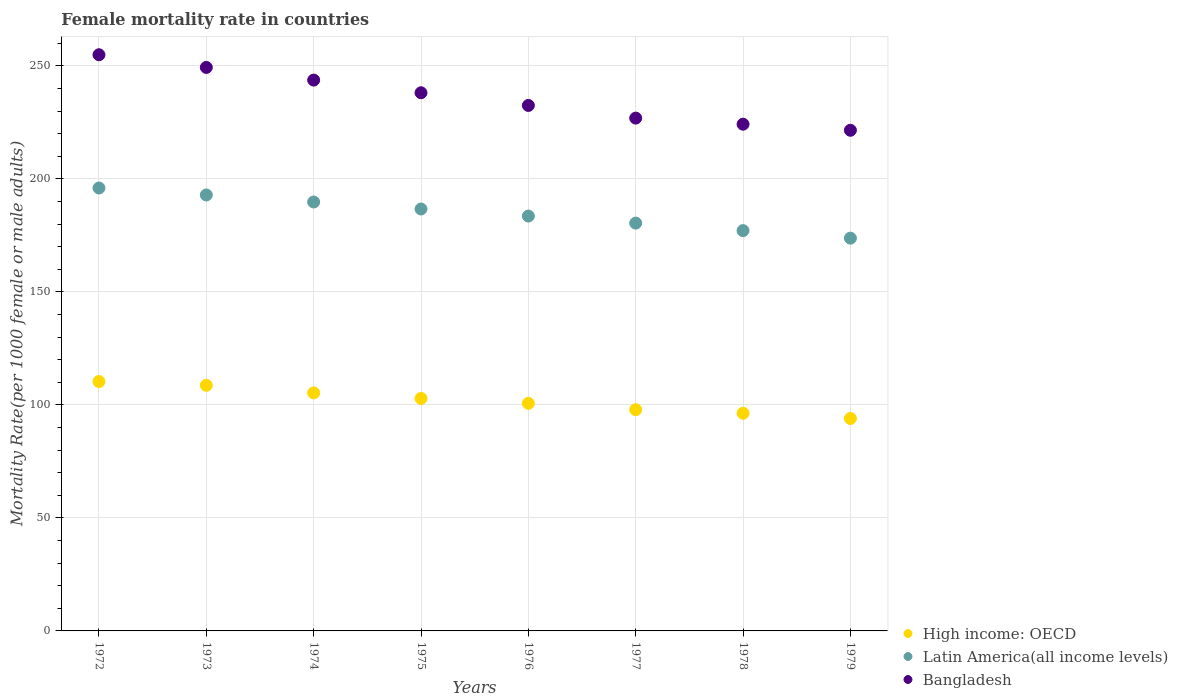Is the number of dotlines equal to the number of legend labels?
Your answer should be very brief. Yes. What is the female mortality rate in High income: OECD in 1976?
Provide a short and direct response. 100.7. Across all years, what is the maximum female mortality rate in High income: OECD?
Your answer should be very brief. 110.35. Across all years, what is the minimum female mortality rate in Bangladesh?
Offer a very short reply. 221.51. In which year was the female mortality rate in Latin America(all income levels) minimum?
Your answer should be compact. 1979. What is the total female mortality rate in Bangladesh in the graph?
Offer a very short reply. 1891.15. What is the difference between the female mortality rate in High income: OECD in 1977 and that in 1979?
Your response must be concise. 3.89. What is the difference between the female mortality rate in Latin America(all income levels) in 1975 and the female mortality rate in Bangladesh in 1978?
Keep it short and to the point. -37.52. What is the average female mortality rate in Bangladesh per year?
Keep it short and to the point. 236.39. In the year 1978, what is the difference between the female mortality rate in High income: OECD and female mortality rate in Bangladesh?
Ensure brevity in your answer.  -127.9. What is the ratio of the female mortality rate in Latin America(all income levels) in 1972 to that in 1975?
Ensure brevity in your answer.  1.05. Is the female mortality rate in Latin America(all income levels) in 1976 less than that in 1978?
Provide a short and direct response. No. Is the difference between the female mortality rate in High income: OECD in 1973 and 1974 greater than the difference between the female mortality rate in Bangladesh in 1973 and 1974?
Offer a very short reply. No. What is the difference between the highest and the second highest female mortality rate in Bangladesh?
Your answer should be very brief. 5.61. What is the difference between the highest and the lowest female mortality rate in Bangladesh?
Keep it short and to the point. 33.41. Is it the case that in every year, the sum of the female mortality rate in Bangladesh and female mortality rate in High income: OECD  is greater than the female mortality rate in Latin America(all income levels)?
Offer a terse response. Yes. Does the female mortality rate in Latin America(all income levels) monotonically increase over the years?
Ensure brevity in your answer.  No. Is the female mortality rate in Latin America(all income levels) strictly greater than the female mortality rate in High income: OECD over the years?
Your response must be concise. Yes. Is the female mortality rate in Bangladesh strictly less than the female mortality rate in High income: OECD over the years?
Make the answer very short. No. What is the title of the graph?
Keep it short and to the point. Female mortality rate in countries. Does "Small states" appear as one of the legend labels in the graph?
Offer a very short reply. No. What is the label or title of the X-axis?
Offer a terse response. Years. What is the label or title of the Y-axis?
Keep it short and to the point. Mortality Rate(per 1000 female or male adults). What is the Mortality Rate(per 1000 female or male adults) in High income: OECD in 1972?
Ensure brevity in your answer.  110.35. What is the Mortality Rate(per 1000 female or male adults) in Latin America(all income levels) in 1972?
Give a very brief answer. 195.97. What is the Mortality Rate(per 1000 female or male adults) of Bangladesh in 1972?
Offer a terse response. 254.92. What is the Mortality Rate(per 1000 female or male adults) in High income: OECD in 1973?
Provide a short and direct response. 108.67. What is the Mortality Rate(per 1000 female or male adults) in Latin America(all income levels) in 1973?
Provide a short and direct response. 192.88. What is the Mortality Rate(per 1000 female or male adults) in Bangladesh in 1973?
Your answer should be compact. 249.31. What is the Mortality Rate(per 1000 female or male adults) of High income: OECD in 1974?
Ensure brevity in your answer.  105.32. What is the Mortality Rate(per 1000 female or male adults) of Latin America(all income levels) in 1974?
Your answer should be compact. 189.78. What is the Mortality Rate(per 1000 female or male adults) in Bangladesh in 1974?
Your answer should be compact. 243.71. What is the Mortality Rate(per 1000 female or male adults) of High income: OECD in 1975?
Provide a succinct answer. 102.86. What is the Mortality Rate(per 1000 female or male adults) of Latin America(all income levels) in 1975?
Provide a succinct answer. 186.68. What is the Mortality Rate(per 1000 female or male adults) of Bangladesh in 1975?
Give a very brief answer. 238.1. What is the Mortality Rate(per 1000 female or male adults) of High income: OECD in 1976?
Keep it short and to the point. 100.7. What is the Mortality Rate(per 1000 female or male adults) in Latin America(all income levels) in 1976?
Give a very brief answer. 183.56. What is the Mortality Rate(per 1000 female or male adults) in Bangladesh in 1976?
Give a very brief answer. 232.5. What is the Mortality Rate(per 1000 female or male adults) of High income: OECD in 1977?
Your response must be concise. 97.89. What is the Mortality Rate(per 1000 female or male adults) in Latin America(all income levels) in 1977?
Ensure brevity in your answer.  180.43. What is the Mortality Rate(per 1000 female or male adults) in Bangladesh in 1977?
Your answer should be compact. 226.89. What is the Mortality Rate(per 1000 female or male adults) in High income: OECD in 1978?
Provide a succinct answer. 96.3. What is the Mortality Rate(per 1000 female or male adults) of Latin America(all income levels) in 1978?
Your response must be concise. 177.11. What is the Mortality Rate(per 1000 female or male adults) of Bangladesh in 1978?
Offer a terse response. 224.2. What is the Mortality Rate(per 1000 female or male adults) of High income: OECD in 1979?
Give a very brief answer. 94. What is the Mortality Rate(per 1000 female or male adults) in Latin America(all income levels) in 1979?
Provide a short and direct response. 173.78. What is the Mortality Rate(per 1000 female or male adults) of Bangladesh in 1979?
Your response must be concise. 221.51. Across all years, what is the maximum Mortality Rate(per 1000 female or male adults) of High income: OECD?
Make the answer very short. 110.35. Across all years, what is the maximum Mortality Rate(per 1000 female or male adults) in Latin America(all income levels)?
Your answer should be very brief. 195.97. Across all years, what is the maximum Mortality Rate(per 1000 female or male adults) in Bangladesh?
Keep it short and to the point. 254.92. Across all years, what is the minimum Mortality Rate(per 1000 female or male adults) in High income: OECD?
Give a very brief answer. 94. Across all years, what is the minimum Mortality Rate(per 1000 female or male adults) in Latin America(all income levels)?
Provide a succinct answer. 173.78. Across all years, what is the minimum Mortality Rate(per 1000 female or male adults) in Bangladesh?
Your answer should be very brief. 221.51. What is the total Mortality Rate(per 1000 female or male adults) in High income: OECD in the graph?
Offer a very short reply. 816.07. What is the total Mortality Rate(per 1000 female or male adults) in Latin America(all income levels) in the graph?
Give a very brief answer. 1480.19. What is the total Mortality Rate(per 1000 female or male adults) of Bangladesh in the graph?
Your response must be concise. 1891.15. What is the difference between the Mortality Rate(per 1000 female or male adults) of High income: OECD in 1972 and that in 1973?
Keep it short and to the point. 1.68. What is the difference between the Mortality Rate(per 1000 female or male adults) of Latin America(all income levels) in 1972 and that in 1973?
Your answer should be very brief. 3.09. What is the difference between the Mortality Rate(per 1000 female or male adults) in Bangladesh in 1972 and that in 1973?
Ensure brevity in your answer.  5.61. What is the difference between the Mortality Rate(per 1000 female or male adults) in High income: OECD in 1972 and that in 1974?
Offer a terse response. 5.03. What is the difference between the Mortality Rate(per 1000 female or male adults) of Latin America(all income levels) in 1972 and that in 1974?
Provide a short and direct response. 6.19. What is the difference between the Mortality Rate(per 1000 female or male adults) of Bangladesh in 1972 and that in 1974?
Provide a short and direct response. 11.21. What is the difference between the Mortality Rate(per 1000 female or male adults) in High income: OECD in 1972 and that in 1975?
Make the answer very short. 7.49. What is the difference between the Mortality Rate(per 1000 female or male adults) of Latin America(all income levels) in 1972 and that in 1975?
Give a very brief answer. 9.3. What is the difference between the Mortality Rate(per 1000 female or male adults) in Bangladesh in 1972 and that in 1975?
Provide a short and direct response. 16.82. What is the difference between the Mortality Rate(per 1000 female or male adults) in High income: OECD in 1972 and that in 1976?
Make the answer very short. 9.64. What is the difference between the Mortality Rate(per 1000 female or male adults) in Latin America(all income levels) in 1972 and that in 1976?
Your answer should be very brief. 12.42. What is the difference between the Mortality Rate(per 1000 female or male adults) in Bangladesh in 1972 and that in 1976?
Make the answer very short. 22.42. What is the difference between the Mortality Rate(per 1000 female or male adults) of High income: OECD in 1972 and that in 1977?
Your answer should be very brief. 12.46. What is the difference between the Mortality Rate(per 1000 female or male adults) in Latin America(all income levels) in 1972 and that in 1977?
Ensure brevity in your answer.  15.54. What is the difference between the Mortality Rate(per 1000 female or male adults) in Bangladesh in 1972 and that in 1977?
Give a very brief answer. 28.03. What is the difference between the Mortality Rate(per 1000 female or male adults) in High income: OECD in 1972 and that in 1978?
Offer a very short reply. 14.05. What is the difference between the Mortality Rate(per 1000 female or male adults) in Latin America(all income levels) in 1972 and that in 1978?
Give a very brief answer. 18.86. What is the difference between the Mortality Rate(per 1000 female or male adults) in Bangladesh in 1972 and that in 1978?
Your response must be concise. 30.72. What is the difference between the Mortality Rate(per 1000 female or male adults) in High income: OECD in 1972 and that in 1979?
Your answer should be very brief. 16.35. What is the difference between the Mortality Rate(per 1000 female or male adults) of Latin America(all income levels) in 1972 and that in 1979?
Offer a very short reply. 22.19. What is the difference between the Mortality Rate(per 1000 female or male adults) in Bangladesh in 1972 and that in 1979?
Offer a very short reply. 33.41. What is the difference between the Mortality Rate(per 1000 female or male adults) in High income: OECD in 1973 and that in 1974?
Give a very brief answer. 3.35. What is the difference between the Mortality Rate(per 1000 female or male adults) in Latin America(all income levels) in 1973 and that in 1974?
Provide a succinct answer. 3.1. What is the difference between the Mortality Rate(per 1000 female or male adults) of Bangladesh in 1973 and that in 1974?
Provide a short and direct response. 5.61. What is the difference between the Mortality Rate(per 1000 female or male adults) of High income: OECD in 1973 and that in 1975?
Your response must be concise. 5.81. What is the difference between the Mortality Rate(per 1000 female or male adults) of Latin America(all income levels) in 1973 and that in 1975?
Make the answer very short. 6.2. What is the difference between the Mortality Rate(per 1000 female or male adults) in Bangladesh in 1973 and that in 1975?
Give a very brief answer. 11.21. What is the difference between the Mortality Rate(per 1000 female or male adults) of High income: OECD in 1973 and that in 1976?
Make the answer very short. 7.96. What is the difference between the Mortality Rate(per 1000 female or male adults) of Latin America(all income levels) in 1973 and that in 1976?
Offer a very short reply. 9.32. What is the difference between the Mortality Rate(per 1000 female or male adults) in Bangladesh in 1973 and that in 1976?
Make the answer very short. 16.82. What is the difference between the Mortality Rate(per 1000 female or male adults) of High income: OECD in 1973 and that in 1977?
Give a very brief answer. 10.78. What is the difference between the Mortality Rate(per 1000 female or male adults) in Latin America(all income levels) in 1973 and that in 1977?
Provide a short and direct response. 12.45. What is the difference between the Mortality Rate(per 1000 female or male adults) in Bangladesh in 1973 and that in 1977?
Give a very brief answer. 22.42. What is the difference between the Mortality Rate(per 1000 female or male adults) of High income: OECD in 1973 and that in 1978?
Ensure brevity in your answer.  12.37. What is the difference between the Mortality Rate(per 1000 female or male adults) of Latin America(all income levels) in 1973 and that in 1978?
Offer a very short reply. 15.77. What is the difference between the Mortality Rate(per 1000 female or male adults) in Bangladesh in 1973 and that in 1978?
Make the answer very short. 25.11. What is the difference between the Mortality Rate(per 1000 female or male adults) of High income: OECD in 1973 and that in 1979?
Offer a terse response. 14.67. What is the difference between the Mortality Rate(per 1000 female or male adults) of Latin America(all income levels) in 1973 and that in 1979?
Your answer should be compact. 19.1. What is the difference between the Mortality Rate(per 1000 female or male adults) of Bangladesh in 1973 and that in 1979?
Ensure brevity in your answer.  27.8. What is the difference between the Mortality Rate(per 1000 female or male adults) of High income: OECD in 1974 and that in 1975?
Keep it short and to the point. 2.46. What is the difference between the Mortality Rate(per 1000 female or male adults) of Latin America(all income levels) in 1974 and that in 1975?
Keep it short and to the point. 3.1. What is the difference between the Mortality Rate(per 1000 female or male adults) in Bangladesh in 1974 and that in 1975?
Your answer should be compact. 5.61. What is the difference between the Mortality Rate(per 1000 female or male adults) of High income: OECD in 1974 and that in 1976?
Ensure brevity in your answer.  4.61. What is the difference between the Mortality Rate(per 1000 female or male adults) in Latin America(all income levels) in 1974 and that in 1976?
Offer a very short reply. 6.22. What is the difference between the Mortality Rate(per 1000 female or male adults) in Bangladesh in 1974 and that in 1976?
Offer a very short reply. 11.21. What is the difference between the Mortality Rate(per 1000 female or male adults) in High income: OECD in 1974 and that in 1977?
Make the answer very short. 7.43. What is the difference between the Mortality Rate(per 1000 female or male adults) in Latin America(all income levels) in 1974 and that in 1977?
Your answer should be compact. 9.35. What is the difference between the Mortality Rate(per 1000 female or male adults) of Bangladesh in 1974 and that in 1977?
Your answer should be very brief. 16.82. What is the difference between the Mortality Rate(per 1000 female or male adults) in High income: OECD in 1974 and that in 1978?
Your response must be concise. 9.02. What is the difference between the Mortality Rate(per 1000 female or male adults) of Latin America(all income levels) in 1974 and that in 1978?
Your answer should be very brief. 12.67. What is the difference between the Mortality Rate(per 1000 female or male adults) of Bangladesh in 1974 and that in 1978?
Your answer should be compact. 19.51. What is the difference between the Mortality Rate(per 1000 female or male adults) in High income: OECD in 1974 and that in 1979?
Give a very brief answer. 11.32. What is the difference between the Mortality Rate(per 1000 female or male adults) of Latin America(all income levels) in 1974 and that in 1979?
Ensure brevity in your answer.  16. What is the difference between the Mortality Rate(per 1000 female or male adults) of Bangladesh in 1974 and that in 1979?
Your answer should be compact. 22.2. What is the difference between the Mortality Rate(per 1000 female or male adults) in High income: OECD in 1975 and that in 1976?
Provide a succinct answer. 2.16. What is the difference between the Mortality Rate(per 1000 female or male adults) in Latin America(all income levels) in 1975 and that in 1976?
Ensure brevity in your answer.  3.12. What is the difference between the Mortality Rate(per 1000 female or male adults) of Bangladesh in 1975 and that in 1976?
Offer a very short reply. 5.61. What is the difference between the Mortality Rate(per 1000 female or male adults) in High income: OECD in 1975 and that in 1977?
Make the answer very short. 4.97. What is the difference between the Mortality Rate(per 1000 female or male adults) of Latin America(all income levels) in 1975 and that in 1977?
Provide a short and direct response. 6.24. What is the difference between the Mortality Rate(per 1000 female or male adults) of Bangladesh in 1975 and that in 1977?
Your response must be concise. 11.21. What is the difference between the Mortality Rate(per 1000 female or male adults) of High income: OECD in 1975 and that in 1978?
Provide a short and direct response. 6.56. What is the difference between the Mortality Rate(per 1000 female or male adults) in Latin America(all income levels) in 1975 and that in 1978?
Offer a very short reply. 9.57. What is the difference between the Mortality Rate(per 1000 female or male adults) in Bangladesh in 1975 and that in 1978?
Keep it short and to the point. 13.9. What is the difference between the Mortality Rate(per 1000 female or male adults) in High income: OECD in 1975 and that in 1979?
Give a very brief answer. 8.86. What is the difference between the Mortality Rate(per 1000 female or male adults) in Latin America(all income levels) in 1975 and that in 1979?
Your answer should be very brief. 12.89. What is the difference between the Mortality Rate(per 1000 female or male adults) in Bangladesh in 1975 and that in 1979?
Keep it short and to the point. 16.59. What is the difference between the Mortality Rate(per 1000 female or male adults) of High income: OECD in 1976 and that in 1977?
Provide a succinct answer. 2.81. What is the difference between the Mortality Rate(per 1000 female or male adults) of Latin America(all income levels) in 1976 and that in 1977?
Your response must be concise. 3.12. What is the difference between the Mortality Rate(per 1000 female or male adults) of Bangladesh in 1976 and that in 1977?
Keep it short and to the point. 5.61. What is the difference between the Mortality Rate(per 1000 female or male adults) of High income: OECD in 1976 and that in 1978?
Your response must be concise. 4.4. What is the difference between the Mortality Rate(per 1000 female or male adults) in Latin America(all income levels) in 1976 and that in 1978?
Provide a succinct answer. 6.45. What is the difference between the Mortality Rate(per 1000 female or male adults) in Bangladesh in 1976 and that in 1978?
Ensure brevity in your answer.  8.3. What is the difference between the Mortality Rate(per 1000 female or male adults) of High income: OECD in 1976 and that in 1979?
Your answer should be very brief. 6.7. What is the difference between the Mortality Rate(per 1000 female or male adults) in Latin America(all income levels) in 1976 and that in 1979?
Make the answer very short. 9.77. What is the difference between the Mortality Rate(per 1000 female or male adults) of Bangladesh in 1976 and that in 1979?
Provide a succinct answer. 10.99. What is the difference between the Mortality Rate(per 1000 female or male adults) in High income: OECD in 1977 and that in 1978?
Make the answer very short. 1.59. What is the difference between the Mortality Rate(per 1000 female or male adults) in Latin America(all income levels) in 1977 and that in 1978?
Offer a very short reply. 3.32. What is the difference between the Mortality Rate(per 1000 female or male adults) of Bangladesh in 1977 and that in 1978?
Provide a short and direct response. 2.69. What is the difference between the Mortality Rate(per 1000 female or male adults) in High income: OECD in 1977 and that in 1979?
Offer a terse response. 3.89. What is the difference between the Mortality Rate(per 1000 female or male adults) of Latin America(all income levels) in 1977 and that in 1979?
Provide a succinct answer. 6.65. What is the difference between the Mortality Rate(per 1000 female or male adults) of Bangladesh in 1977 and that in 1979?
Offer a very short reply. 5.38. What is the difference between the Mortality Rate(per 1000 female or male adults) in High income: OECD in 1978 and that in 1979?
Provide a short and direct response. 2.3. What is the difference between the Mortality Rate(per 1000 female or male adults) in Latin America(all income levels) in 1978 and that in 1979?
Your response must be concise. 3.33. What is the difference between the Mortality Rate(per 1000 female or male adults) in Bangladesh in 1978 and that in 1979?
Offer a very short reply. 2.69. What is the difference between the Mortality Rate(per 1000 female or male adults) of High income: OECD in 1972 and the Mortality Rate(per 1000 female or male adults) of Latin America(all income levels) in 1973?
Provide a short and direct response. -82.53. What is the difference between the Mortality Rate(per 1000 female or male adults) of High income: OECD in 1972 and the Mortality Rate(per 1000 female or male adults) of Bangladesh in 1973?
Your answer should be very brief. -138.97. What is the difference between the Mortality Rate(per 1000 female or male adults) of Latin America(all income levels) in 1972 and the Mortality Rate(per 1000 female or male adults) of Bangladesh in 1973?
Keep it short and to the point. -53.34. What is the difference between the Mortality Rate(per 1000 female or male adults) of High income: OECD in 1972 and the Mortality Rate(per 1000 female or male adults) of Latin America(all income levels) in 1974?
Your response must be concise. -79.44. What is the difference between the Mortality Rate(per 1000 female or male adults) in High income: OECD in 1972 and the Mortality Rate(per 1000 female or male adults) in Bangladesh in 1974?
Give a very brief answer. -133.36. What is the difference between the Mortality Rate(per 1000 female or male adults) in Latin America(all income levels) in 1972 and the Mortality Rate(per 1000 female or male adults) in Bangladesh in 1974?
Keep it short and to the point. -47.74. What is the difference between the Mortality Rate(per 1000 female or male adults) of High income: OECD in 1972 and the Mortality Rate(per 1000 female or male adults) of Latin America(all income levels) in 1975?
Make the answer very short. -76.33. What is the difference between the Mortality Rate(per 1000 female or male adults) of High income: OECD in 1972 and the Mortality Rate(per 1000 female or male adults) of Bangladesh in 1975?
Give a very brief answer. -127.76. What is the difference between the Mortality Rate(per 1000 female or male adults) of Latin America(all income levels) in 1972 and the Mortality Rate(per 1000 female or male adults) of Bangladesh in 1975?
Your answer should be compact. -42.13. What is the difference between the Mortality Rate(per 1000 female or male adults) of High income: OECD in 1972 and the Mortality Rate(per 1000 female or male adults) of Latin America(all income levels) in 1976?
Provide a short and direct response. -73.21. What is the difference between the Mortality Rate(per 1000 female or male adults) in High income: OECD in 1972 and the Mortality Rate(per 1000 female or male adults) in Bangladesh in 1976?
Your answer should be compact. -122.15. What is the difference between the Mortality Rate(per 1000 female or male adults) of Latin America(all income levels) in 1972 and the Mortality Rate(per 1000 female or male adults) of Bangladesh in 1976?
Offer a very short reply. -36.53. What is the difference between the Mortality Rate(per 1000 female or male adults) in High income: OECD in 1972 and the Mortality Rate(per 1000 female or male adults) in Latin America(all income levels) in 1977?
Offer a very short reply. -70.09. What is the difference between the Mortality Rate(per 1000 female or male adults) in High income: OECD in 1972 and the Mortality Rate(per 1000 female or male adults) in Bangladesh in 1977?
Your answer should be very brief. -116.55. What is the difference between the Mortality Rate(per 1000 female or male adults) of Latin America(all income levels) in 1972 and the Mortality Rate(per 1000 female or male adults) of Bangladesh in 1977?
Provide a short and direct response. -30.92. What is the difference between the Mortality Rate(per 1000 female or male adults) of High income: OECD in 1972 and the Mortality Rate(per 1000 female or male adults) of Latin America(all income levels) in 1978?
Give a very brief answer. -66.76. What is the difference between the Mortality Rate(per 1000 female or male adults) in High income: OECD in 1972 and the Mortality Rate(per 1000 female or male adults) in Bangladesh in 1978?
Provide a short and direct response. -113.86. What is the difference between the Mortality Rate(per 1000 female or male adults) of Latin America(all income levels) in 1972 and the Mortality Rate(per 1000 female or male adults) of Bangladesh in 1978?
Offer a terse response. -28.23. What is the difference between the Mortality Rate(per 1000 female or male adults) of High income: OECD in 1972 and the Mortality Rate(per 1000 female or male adults) of Latin America(all income levels) in 1979?
Your answer should be compact. -63.44. What is the difference between the Mortality Rate(per 1000 female or male adults) in High income: OECD in 1972 and the Mortality Rate(per 1000 female or male adults) in Bangladesh in 1979?
Make the answer very short. -111.17. What is the difference between the Mortality Rate(per 1000 female or male adults) of Latin America(all income levels) in 1972 and the Mortality Rate(per 1000 female or male adults) of Bangladesh in 1979?
Offer a terse response. -25.54. What is the difference between the Mortality Rate(per 1000 female or male adults) in High income: OECD in 1973 and the Mortality Rate(per 1000 female or male adults) in Latin America(all income levels) in 1974?
Keep it short and to the point. -81.12. What is the difference between the Mortality Rate(per 1000 female or male adults) in High income: OECD in 1973 and the Mortality Rate(per 1000 female or male adults) in Bangladesh in 1974?
Make the answer very short. -135.04. What is the difference between the Mortality Rate(per 1000 female or male adults) of Latin America(all income levels) in 1973 and the Mortality Rate(per 1000 female or male adults) of Bangladesh in 1974?
Your answer should be compact. -50.83. What is the difference between the Mortality Rate(per 1000 female or male adults) of High income: OECD in 1973 and the Mortality Rate(per 1000 female or male adults) of Latin America(all income levels) in 1975?
Provide a short and direct response. -78.01. What is the difference between the Mortality Rate(per 1000 female or male adults) of High income: OECD in 1973 and the Mortality Rate(per 1000 female or male adults) of Bangladesh in 1975?
Ensure brevity in your answer.  -129.44. What is the difference between the Mortality Rate(per 1000 female or male adults) of Latin America(all income levels) in 1973 and the Mortality Rate(per 1000 female or male adults) of Bangladesh in 1975?
Make the answer very short. -45.22. What is the difference between the Mortality Rate(per 1000 female or male adults) in High income: OECD in 1973 and the Mortality Rate(per 1000 female or male adults) in Latin America(all income levels) in 1976?
Offer a terse response. -74.89. What is the difference between the Mortality Rate(per 1000 female or male adults) in High income: OECD in 1973 and the Mortality Rate(per 1000 female or male adults) in Bangladesh in 1976?
Your answer should be compact. -123.83. What is the difference between the Mortality Rate(per 1000 female or male adults) in Latin America(all income levels) in 1973 and the Mortality Rate(per 1000 female or male adults) in Bangladesh in 1976?
Provide a short and direct response. -39.62. What is the difference between the Mortality Rate(per 1000 female or male adults) in High income: OECD in 1973 and the Mortality Rate(per 1000 female or male adults) in Latin America(all income levels) in 1977?
Offer a terse response. -71.77. What is the difference between the Mortality Rate(per 1000 female or male adults) in High income: OECD in 1973 and the Mortality Rate(per 1000 female or male adults) in Bangladesh in 1977?
Keep it short and to the point. -118.23. What is the difference between the Mortality Rate(per 1000 female or male adults) in Latin America(all income levels) in 1973 and the Mortality Rate(per 1000 female or male adults) in Bangladesh in 1977?
Keep it short and to the point. -34.01. What is the difference between the Mortality Rate(per 1000 female or male adults) of High income: OECD in 1973 and the Mortality Rate(per 1000 female or male adults) of Latin America(all income levels) in 1978?
Offer a terse response. -68.44. What is the difference between the Mortality Rate(per 1000 female or male adults) of High income: OECD in 1973 and the Mortality Rate(per 1000 female or male adults) of Bangladesh in 1978?
Provide a short and direct response. -115.54. What is the difference between the Mortality Rate(per 1000 female or male adults) of Latin America(all income levels) in 1973 and the Mortality Rate(per 1000 female or male adults) of Bangladesh in 1978?
Make the answer very short. -31.32. What is the difference between the Mortality Rate(per 1000 female or male adults) of High income: OECD in 1973 and the Mortality Rate(per 1000 female or male adults) of Latin America(all income levels) in 1979?
Offer a very short reply. -65.12. What is the difference between the Mortality Rate(per 1000 female or male adults) of High income: OECD in 1973 and the Mortality Rate(per 1000 female or male adults) of Bangladesh in 1979?
Provide a short and direct response. -112.85. What is the difference between the Mortality Rate(per 1000 female or male adults) in Latin America(all income levels) in 1973 and the Mortality Rate(per 1000 female or male adults) in Bangladesh in 1979?
Ensure brevity in your answer.  -28.63. What is the difference between the Mortality Rate(per 1000 female or male adults) in High income: OECD in 1974 and the Mortality Rate(per 1000 female or male adults) in Latin America(all income levels) in 1975?
Provide a short and direct response. -81.36. What is the difference between the Mortality Rate(per 1000 female or male adults) of High income: OECD in 1974 and the Mortality Rate(per 1000 female or male adults) of Bangladesh in 1975?
Give a very brief answer. -132.79. What is the difference between the Mortality Rate(per 1000 female or male adults) in Latin America(all income levels) in 1974 and the Mortality Rate(per 1000 female or male adults) in Bangladesh in 1975?
Provide a short and direct response. -48.32. What is the difference between the Mortality Rate(per 1000 female or male adults) of High income: OECD in 1974 and the Mortality Rate(per 1000 female or male adults) of Latin America(all income levels) in 1976?
Your response must be concise. -78.24. What is the difference between the Mortality Rate(per 1000 female or male adults) in High income: OECD in 1974 and the Mortality Rate(per 1000 female or male adults) in Bangladesh in 1976?
Your response must be concise. -127.18. What is the difference between the Mortality Rate(per 1000 female or male adults) of Latin America(all income levels) in 1974 and the Mortality Rate(per 1000 female or male adults) of Bangladesh in 1976?
Ensure brevity in your answer.  -42.72. What is the difference between the Mortality Rate(per 1000 female or male adults) in High income: OECD in 1974 and the Mortality Rate(per 1000 female or male adults) in Latin America(all income levels) in 1977?
Offer a terse response. -75.12. What is the difference between the Mortality Rate(per 1000 female or male adults) in High income: OECD in 1974 and the Mortality Rate(per 1000 female or male adults) in Bangladesh in 1977?
Offer a very short reply. -121.58. What is the difference between the Mortality Rate(per 1000 female or male adults) of Latin America(all income levels) in 1974 and the Mortality Rate(per 1000 female or male adults) of Bangladesh in 1977?
Offer a terse response. -37.11. What is the difference between the Mortality Rate(per 1000 female or male adults) of High income: OECD in 1974 and the Mortality Rate(per 1000 female or male adults) of Latin America(all income levels) in 1978?
Ensure brevity in your answer.  -71.79. What is the difference between the Mortality Rate(per 1000 female or male adults) of High income: OECD in 1974 and the Mortality Rate(per 1000 female or male adults) of Bangladesh in 1978?
Ensure brevity in your answer.  -118.89. What is the difference between the Mortality Rate(per 1000 female or male adults) in Latin America(all income levels) in 1974 and the Mortality Rate(per 1000 female or male adults) in Bangladesh in 1978?
Provide a short and direct response. -34.42. What is the difference between the Mortality Rate(per 1000 female or male adults) in High income: OECD in 1974 and the Mortality Rate(per 1000 female or male adults) in Latin America(all income levels) in 1979?
Provide a succinct answer. -68.47. What is the difference between the Mortality Rate(per 1000 female or male adults) of High income: OECD in 1974 and the Mortality Rate(per 1000 female or male adults) of Bangladesh in 1979?
Offer a terse response. -116.2. What is the difference between the Mortality Rate(per 1000 female or male adults) in Latin America(all income levels) in 1974 and the Mortality Rate(per 1000 female or male adults) in Bangladesh in 1979?
Provide a short and direct response. -31.73. What is the difference between the Mortality Rate(per 1000 female or male adults) of High income: OECD in 1975 and the Mortality Rate(per 1000 female or male adults) of Latin America(all income levels) in 1976?
Provide a short and direct response. -80.7. What is the difference between the Mortality Rate(per 1000 female or male adults) of High income: OECD in 1975 and the Mortality Rate(per 1000 female or male adults) of Bangladesh in 1976?
Offer a terse response. -129.64. What is the difference between the Mortality Rate(per 1000 female or male adults) in Latin America(all income levels) in 1975 and the Mortality Rate(per 1000 female or male adults) in Bangladesh in 1976?
Your answer should be compact. -45.82. What is the difference between the Mortality Rate(per 1000 female or male adults) in High income: OECD in 1975 and the Mortality Rate(per 1000 female or male adults) in Latin America(all income levels) in 1977?
Keep it short and to the point. -77.58. What is the difference between the Mortality Rate(per 1000 female or male adults) of High income: OECD in 1975 and the Mortality Rate(per 1000 female or male adults) of Bangladesh in 1977?
Give a very brief answer. -124.04. What is the difference between the Mortality Rate(per 1000 female or male adults) in Latin America(all income levels) in 1975 and the Mortality Rate(per 1000 female or male adults) in Bangladesh in 1977?
Your answer should be compact. -40.22. What is the difference between the Mortality Rate(per 1000 female or male adults) in High income: OECD in 1975 and the Mortality Rate(per 1000 female or male adults) in Latin America(all income levels) in 1978?
Provide a short and direct response. -74.25. What is the difference between the Mortality Rate(per 1000 female or male adults) in High income: OECD in 1975 and the Mortality Rate(per 1000 female or male adults) in Bangladesh in 1978?
Provide a succinct answer. -121.34. What is the difference between the Mortality Rate(per 1000 female or male adults) in Latin America(all income levels) in 1975 and the Mortality Rate(per 1000 female or male adults) in Bangladesh in 1978?
Provide a short and direct response. -37.52. What is the difference between the Mortality Rate(per 1000 female or male adults) in High income: OECD in 1975 and the Mortality Rate(per 1000 female or male adults) in Latin America(all income levels) in 1979?
Offer a very short reply. -70.93. What is the difference between the Mortality Rate(per 1000 female or male adults) in High income: OECD in 1975 and the Mortality Rate(per 1000 female or male adults) in Bangladesh in 1979?
Provide a short and direct response. -118.65. What is the difference between the Mortality Rate(per 1000 female or male adults) in Latin America(all income levels) in 1975 and the Mortality Rate(per 1000 female or male adults) in Bangladesh in 1979?
Your response must be concise. -34.83. What is the difference between the Mortality Rate(per 1000 female or male adults) in High income: OECD in 1976 and the Mortality Rate(per 1000 female or male adults) in Latin America(all income levels) in 1977?
Keep it short and to the point. -79.73. What is the difference between the Mortality Rate(per 1000 female or male adults) in High income: OECD in 1976 and the Mortality Rate(per 1000 female or male adults) in Bangladesh in 1977?
Make the answer very short. -126.19. What is the difference between the Mortality Rate(per 1000 female or male adults) in Latin America(all income levels) in 1976 and the Mortality Rate(per 1000 female or male adults) in Bangladesh in 1977?
Your answer should be compact. -43.34. What is the difference between the Mortality Rate(per 1000 female or male adults) of High income: OECD in 1976 and the Mortality Rate(per 1000 female or male adults) of Latin America(all income levels) in 1978?
Make the answer very short. -76.41. What is the difference between the Mortality Rate(per 1000 female or male adults) in High income: OECD in 1976 and the Mortality Rate(per 1000 female or male adults) in Bangladesh in 1978?
Offer a very short reply. -123.5. What is the difference between the Mortality Rate(per 1000 female or male adults) in Latin America(all income levels) in 1976 and the Mortality Rate(per 1000 female or male adults) in Bangladesh in 1978?
Ensure brevity in your answer.  -40.64. What is the difference between the Mortality Rate(per 1000 female or male adults) of High income: OECD in 1976 and the Mortality Rate(per 1000 female or male adults) of Latin America(all income levels) in 1979?
Offer a very short reply. -73.08. What is the difference between the Mortality Rate(per 1000 female or male adults) in High income: OECD in 1976 and the Mortality Rate(per 1000 female or male adults) in Bangladesh in 1979?
Provide a succinct answer. -120.81. What is the difference between the Mortality Rate(per 1000 female or male adults) of Latin America(all income levels) in 1976 and the Mortality Rate(per 1000 female or male adults) of Bangladesh in 1979?
Offer a very short reply. -37.95. What is the difference between the Mortality Rate(per 1000 female or male adults) of High income: OECD in 1977 and the Mortality Rate(per 1000 female or male adults) of Latin America(all income levels) in 1978?
Provide a short and direct response. -79.22. What is the difference between the Mortality Rate(per 1000 female or male adults) of High income: OECD in 1977 and the Mortality Rate(per 1000 female or male adults) of Bangladesh in 1978?
Your response must be concise. -126.31. What is the difference between the Mortality Rate(per 1000 female or male adults) in Latin America(all income levels) in 1977 and the Mortality Rate(per 1000 female or male adults) in Bangladesh in 1978?
Your answer should be compact. -43.77. What is the difference between the Mortality Rate(per 1000 female or male adults) of High income: OECD in 1977 and the Mortality Rate(per 1000 female or male adults) of Latin America(all income levels) in 1979?
Your answer should be very brief. -75.89. What is the difference between the Mortality Rate(per 1000 female or male adults) of High income: OECD in 1977 and the Mortality Rate(per 1000 female or male adults) of Bangladesh in 1979?
Keep it short and to the point. -123.62. What is the difference between the Mortality Rate(per 1000 female or male adults) of Latin America(all income levels) in 1977 and the Mortality Rate(per 1000 female or male adults) of Bangladesh in 1979?
Ensure brevity in your answer.  -41.08. What is the difference between the Mortality Rate(per 1000 female or male adults) in High income: OECD in 1978 and the Mortality Rate(per 1000 female or male adults) in Latin America(all income levels) in 1979?
Provide a succinct answer. -77.49. What is the difference between the Mortality Rate(per 1000 female or male adults) of High income: OECD in 1978 and the Mortality Rate(per 1000 female or male adults) of Bangladesh in 1979?
Offer a very short reply. -125.21. What is the difference between the Mortality Rate(per 1000 female or male adults) in Latin America(all income levels) in 1978 and the Mortality Rate(per 1000 female or male adults) in Bangladesh in 1979?
Ensure brevity in your answer.  -44.4. What is the average Mortality Rate(per 1000 female or male adults) in High income: OECD per year?
Ensure brevity in your answer.  102.01. What is the average Mortality Rate(per 1000 female or male adults) in Latin America(all income levels) per year?
Make the answer very short. 185.02. What is the average Mortality Rate(per 1000 female or male adults) in Bangladesh per year?
Keep it short and to the point. 236.39. In the year 1972, what is the difference between the Mortality Rate(per 1000 female or male adults) in High income: OECD and Mortality Rate(per 1000 female or male adults) in Latin America(all income levels)?
Your answer should be very brief. -85.63. In the year 1972, what is the difference between the Mortality Rate(per 1000 female or male adults) in High income: OECD and Mortality Rate(per 1000 female or male adults) in Bangladesh?
Make the answer very short. -144.58. In the year 1972, what is the difference between the Mortality Rate(per 1000 female or male adults) in Latin America(all income levels) and Mortality Rate(per 1000 female or male adults) in Bangladesh?
Your response must be concise. -58.95. In the year 1973, what is the difference between the Mortality Rate(per 1000 female or male adults) in High income: OECD and Mortality Rate(per 1000 female or male adults) in Latin America(all income levels)?
Give a very brief answer. -84.21. In the year 1973, what is the difference between the Mortality Rate(per 1000 female or male adults) of High income: OECD and Mortality Rate(per 1000 female or male adults) of Bangladesh?
Make the answer very short. -140.65. In the year 1973, what is the difference between the Mortality Rate(per 1000 female or male adults) in Latin America(all income levels) and Mortality Rate(per 1000 female or male adults) in Bangladesh?
Offer a very short reply. -56.44. In the year 1974, what is the difference between the Mortality Rate(per 1000 female or male adults) of High income: OECD and Mortality Rate(per 1000 female or male adults) of Latin America(all income levels)?
Your answer should be compact. -84.47. In the year 1974, what is the difference between the Mortality Rate(per 1000 female or male adults) in High income: OECD and Mortality Rate(per 1000 female or male adults) in Bangladesh?
Your response must be concise. -138.39. In the year 1974, what is the difference between the Mortality Rate(per 1000 female or male adults) of Latin America(all income levels) and Mortality Rate(per 1000 female or male adults) of Bangladesh?
Provide a succinct answer. -53.93. In the year 1975, what is the difference between the Mortality Rate(per 1000 female or male adults) in High income: OECD and Mortality Rate(per 1000 female or male adults) in Latin America(all income levels)?
Your answer should be compact. -83.82. In the year 1975, what is the difference between the Mortality Rate(per 1000 female or male adults) in High income: OECD and Mortality Rate(per 1000 female or male adults) in Bangladesh?
Provide a succinct answer. -135.25. In the year 1975, what is the difference between the Mortality Rate(per 1000 female or male adults) of Latin America(all income levels) and Mortality Rate(per 1000 female or male adults) of Bangladesh?
Your answer should be compact. -51.43. In the year 1976, what is the difference between the Mortality Rate(per 1000 female or male adults) in High income: OECD and Mortality Rate(per 1000 female or male adults) in Latin America(all income levels)?
Your answer should be very brief. -82.86. In the year 1976, what is the difference between the Mortality Rate(per 1000 female or male adults) in High income: OECD and Mortality Rate(per 1000 female or male adults) in Bangladesh?
Your answer should be very brief. -131.8. In the year 1976, what is the difference between the Mortality Rate(per 1000 female or male adults) in Latin America(all income levels) and Mortality Rate(per 1000 female or male adults) in Bangladesh?
Make the answer very short. -48.94. In the year 1977, what is the difference between the Mortality Rate(per 1000 female or male adults) of High income: OECD and Mortality Rate(per 1000 female or male adults) of Latin America(all income levels)?
Offer a very short reply. -82.54. In the year 1977, what is the difference between the Mortality Rate(per 1000 female or male adults) of High income: OECD and Mortality Rate(per 1000 female or male adults) of Bangladesh?
Your answer should be very brief. -129. In the year 1977, what is the difference between the Mortality Rate(per 1000 female or male adults) of Latin America(all income levels) and Mortality Rate(per 1000 female or male adults) of Bangladesh?
Your answer should be compact. -46.46. In the year 1978, what is the difference between the Mortality Rate(per 1000 female or male adults) of High income: OECD and Mortality Rate(per 1000 female or male adults) of Latin America(all income levels)?
Offer a very short reply. -80.81. In the year 1978, what is the difference between the Mortality Rate(per 1000 female or male adults) of High income: OECD and Mortality Rate(per 1000 female or male adults) of Bangladesh?
Offer a terse response. -127.9. In the year 1978, what is the difference between the Mortality Rate(per 1000 female or male adults) in Latin America(all income levels) and Mortality Rate(per 1000 female or male adults) in Bangladesh?
Give a very brief answer. -47.09. In the year 1979, what is the difference between the Mortality Rate(per 1000 female or male adults) in High income: OECD and Mortality Rate(per 1000 female or male adults) in Latin America(all income levels)?
Your response must be concise. -79.79. In the year 1979, what is the difference between the Mortality Rate(per 1000 female or male adults) in High income: OECD and Mortality Rate(per 1000 female or male adults) in Bangladesh?
Offer a very short reply. -127.51. In the year 1979, what is the difference between the Mortality Rate(per 1000 female or male adults) in Latin America(all income levels) and Mortality Rate(per 1000 female or male adults) in Bangladesh?
Your answer should be compact. -47.73. What is the ratio of the Mortality Rate(per 1000 female or male adults) of High income: OECD in 1972 to that in 1973?
Offer a very short reply. 1.02. What is the ratio of the Mortality Rate(per 1000 female or male adults) in Latin America(all income levels) in 1972 to that in 1973?
Provide a succinct answer. 1.02. What is the ratio of the Mortality Rate(per 1000 female or male adults) in Bangladesh in 1972 to that in 1973?
Offer a terse response. 1.02. What is the ratio of the Mortality Rate(per 1000 female or male adults) in High income: OECD in 1972 to that in 1974?
Offer a terse response. 1.05. What is the ratio of the Mortality Rate(per 1000 female or male adults) of Latin America(all income levels) in 1972 to that in 1974?
Ensure brevity in your answer.  1.03. What is the ratio of the Mortality Rate(per 1000 female or male adults) in Bangladesh in 1972 to that in 1974?
Provide a short and direct response. 1.05. What is the ratio of the Mortality Rate(per 1000 female or male adults) of High income: OECD in 1972 to that in 1975?
Provide a succinct answer. 1.07. What is the ratio of the Mortality Rate(per 1000 female or male adults) of Latin America(all income levels) in 1972 to that in 1975?
Provide a short and direct response. 1.05. What is the ratio of the Mortality Rate(per 1000 female or male adults) in Bangladesh in 1972 to that in 1975?
Ensure brevity in your answer.  1.07. What is the ratio of the Mortality Rate(per 1000 female or male adults) in High income: OECD in 1972 to that in 1976?
Offer a terse response. 1.1. What is the ratio of the Mortality Rate(per 1000 female or male adults) of Latin America(all income levels) in 1972 to that in 1976?
Offer a very short reply. 1.07. What is the ratio of the Mortality Rate(per 1000 female or male adults) of Bangladesh in 1972 to that in 1976?
Make the answer very short. 1.1. What is the ratio of the Mortality Rate(per 1000 female or male adults) of High income: OECD in 1972 to that in 1977?
Keep it short and to the point. 1.13. What is the ratio of the Mortality Rate(per 1000 female or male adults) in Latin America(all income levels) in 1972 to that in 1977?
Your answer should be very brief. 1.09. What is the ratio of the Mortality Rate(per 1000 female or male adults) of Bangladesh in 1972 to that in 1977?
Offer a terse response. 1.12. What is the ratio of the Mortality Rate(per 1000 female or male adults) of High income: OECD in 1972 to that in 1978?
Offer a very short reply. 1.15. What is the ratio of the Mortality Rate(per 1000 female or male adults) in Latin America(all income levels) in 1972 to that in 1978?
Your answer should be compact. 1.11. What is the ratio of the Mortality Rate(per 1000 female or male adults) in Bangladesh in 1972 to that in 1978?
Provide a short and direct response. 1.14. What is the ratio of the Mortality Rate(per 1000 female or male adults) of High income: OECD in 1972 to that in 1979?
Keep it short and to the point. 1.17. What is the ratio of the Mortality Rate(per 1000 female or male adults) of Latin America(all income levels) in 1972 to that in 1979?
Give a very brief answer. 1.13. What is the ratio of the Mortality Rate(per 1000 female or male adults) of Bangladesh in 1972 to that in 1979?
Your answer should be compact. 1.15. What is the ratio of the Mortality Rate(per 1000 female or male adults) in High income: OECD in 1973 to that in 1974?
Offer a terse response. 1.03. What is the ratio of the Mortality Rate(per 1000 female or male adults) in Latin America(all income levels) in 1973 to that in 1974?
Your response must be concise. 1.02. What is the ratio of the Mortality Rate(per 1000 female or male adults) in High income: OECD in 1973 to that in 1975?
Provide a short and direct response. 1.06. What is the ratio of the Mortality Rate(per 1000 female or male adults) in Latin America(all income levels) in 1973 to that in 1975?
Your response must be concise. 1.03. What is the ratio of the Mortality Rate(per 1000 female or male adults) of Bangladesh in 1973 to that in 1975?
Your answer should be compact. 1.05. What is the ratio of the Mortality Rate(per 1000 female or male adults) of High income: OECD in 1973 to that in 1976?
Provide a succinct answer. 1.08. What is the ratio of the Mortality Rate(per 1000 female or male adults) of Latin America(all income levels) in 1973 to that in 1976?
Provide a succinct answer. 1.05. What is the ratio of the Mortality Rate(per 1000 female or male adults) of Bangladesh in 1973 to that in 1976?
Keep it short and to the point. 1.07. What is the ratio of the Mortality Rate(per 1000 female or male adults) of High income: OECD in 1973 to that in 1977?
Your answer should be compact. 1.11. What is the ratio of the Mortality Rate(per 1000 female or male adults) of Latin America(all income levels) in 1973 to that in 1977?
Keep it short and to the point. 1.07. What is the ratio of the Mortality Rate(per 1000 female or male adults) in Bangladesh in 1973 to that in 1977?
Provide a succinct answer. 1.1. What is the ratio of the Mortality Rate(per 1000 female or male adults) of High income: OECD in 1973 to that in 1978?
Offer a terse response. 1.13. What is the ratio of the Mortality Rate(per 1000 female or male adults) in Latin America(all income levels) in 1973 to that in 1978?
Make the answer very short. 1.09. What is the ratio of the Mortality Rate(per 1000 female or male adults) of Bangladesh in 1973 to that in 1978?
Provide a short and direct response. 1.11. What is the ratio of the Mortality Rate(per 1000 female or male adults) of High income: OECD in 1973 to that in 1979?
Keep it short and to the point. 1.16. What is the ratio of the Mortality Rate(per 1000 female or male adults) in Latin America(all income levels) in 1973 to that in 1979?
Your answer should be compact. 1.11. What is the ratio of the Mortality Rate(per 1000 female or male adults) of Bangladesh in 1973 to that in 1979?
Your response must be concise. 1.13. What is the ratio of the Mortality Rate(per 1000 female or male adults) of High income: OECD in 1974 to that in 1975?
Provide a short and direct response. 1.02. What is the ratio of the Mortality Rate(per 1000 female or male adults) of Latin America(all income levels) in 1974 to that in 1975?
Your answer should be very brief. 1.02. What is the ratio of the Mortality Rate(per 1000 female or male adults) in Bangladesh in 1974 to that in 1975?
Provide a short and direct response. 1.02. What is the ratio of the Mortality Rate(per 1000 female or male adults) in High income: OECD in 1974 to that in 1976?
Give a very brief answer. 1.05. What is the ratio of the Mortality Rate(per 1000 female or male adults) in Latin America(all income levels) in 1974 to that in 1976?
Provide a short and direct response. 1.03. What is the ratio of the Mortality Rate(per 1000 female or male adults) in Bangladesh in 1974 to that in 1976?
Your answer should be very brief. 1.05. What is the ratio of the Mortality Rate(per 1000 female or male adults) in High income: OECD in 1974 to that in 1977?
Provide a succinct answer. 1.08. What is the ratio of the Mortality Rate(per 1000 female or male adults) in Latin America(all income levels) in 1974 to that in 1977?
Your response must be concise. 1.05. What is the ratio of the Mortality Rate(per 1000 female or male adults) of Bangladesh in 1974 to that in 1977?
Make the answer very short. 1.07. What is the ratio of the Mortality Rate(per 1000 female or male adults) of High income: OECD in 1974 to that in 1978?
Provide a short and direct response. 1.09. What is the ratio of the Mortality Rate(per 1000 female or male adults) of Latin America(all income levels) in 1974 to that in 1978?
Make the answer very short. 1.07. What is the ratio of the Mortality Rate(per 1000 female or male adults) of Bangladesh in 1974 to that in 1978?
Keep it short and to the point. 1.09. What is the ratio of the Mortality Rate(per 1000 female or male adults) in High income: OECD in 1974 to that in 1979?
Offer a very short reply. 1.12. What is the ratio of the Mortality Rate(per 1000 female or male adults) in Latin America(all income levels) in 1974 to that in 1979?
Make the answer very short. 1.09. What is the ratio of the Mortality Rate(per 1000 female or male adults) in Bangladesh in 1974 to that in 1979?
Your answer should be very brief. 1.1. What is the ratio of the Mortality Rate(per 1000 female or male adults) in High income: OECD in 1975 to that in 1976?
Provide a short and direct response. 1.02. What is the ratio of the Mortality Rate(per 1000 female or male adults) of Bangladesh in 1975 to that in 1976?
Keep it short and to the point. 1.02. What is the ratio of the Mortality Rate(per 1000 female or male adults) of High income: OECD in 1975 to that in 1977?
Offer a very short reply. 1.05. What is the ratio of the Mortality Rate(per 1000 female or male adults) of Latin America(all income levels) in 1975 to that in 1977?
Keep it short and to the point. 1.03. What is the ratio of the Mortality Rate(per 1000 female or male adults) in Bangladesh in 1975 to that in 1977?
Make the answer very short. 1.05. What is the ratio of the Mortality Rate(per 1000 female or male adults) in High income: OECD in 1975 to that in 1978?
Make the answer very short. 1.07. What is the ratio of the Mortality Rate(per 1000 female or male adults) in Latin America(all income levels) in 1975 to that in 1978?
Provide a succinct answer. 1.05. What is the ratio of the Mortality Rate(per 1000 female or male adults) in Bangladesh in 1975 to that in 1978?
Offer a very short reply. 1.06. What is the ratio of the Mortality Rate(per 1000 female or male adults) in High income: OECD in 1975 to that in 1979?
Your response must be concise. 1.09. What is the ratio of the Mortality Rate(per 1000 female or male adults) in Latin America(all income levels) in 1975 to that in 1979?
Make the answer very short. 1.07. What is the ratio of the Mortality Rate(per 1000 female or male adults) of Bangladesh in 1975 to that in 1979?
Provide a succinct answer. 1.07. What is the ratio of the Mortality Rate(per 1000 female or male adults) of High income: OECD in 1976 to that in 1977?
Your answer should be very brief. 1.03. What is the ratio of the Mortality Rate(per 1000 female or male adults) of Latin America(all income levels) in 1976 to that in 1977?
Provide a succinct answer. 1.02. What is the ratio of the Mortality Rate(per 1000 female or male adults) of Bangladesh in 1976 to that in 1977?
Provide a short and direct response. 1.02. What is the ratio of the Mortality Rate(per 1000 female or male adults) in High income: OECD in 1976 to that in 1978?
Offer a very short reply. 1.05. What is the ratio of the Mortality Rate(per 1000 female or male adults) in Latin America(all income levels) in 1976 to that in 1978?
Your answer should be compact. 1.04. What is the ratio of the Mortality Rate(per 1000 female or male adults) of Bangladesh in 1976 to that in 1978?
Offer a terse response. 1.04. What is the ratio of the Mortality Rate(per 1000 female or male adults) of High income: OECD in 1976 to that in 1979?
Make the answer very short. 1.07. What is the ratio of the Mortality Rate(per 1000 female or male adults) of Latin America(all income levels) in 1976 to that in 1979?
Keep it short and to the point. 1.06. What is the ratio of the Mortality Rate(per 1000 female or male adults) in Bangladesh in 1976 to that in 1979?
Your answer should be very brief. 1.05. What is the ratio of the Mortality Rate(per 1000 female or male adults) of High income: OECD in 1977 to that in 1978?
Offer a terse response. 1.02. What is the ratio of the Mortality Rate(per 1000 female or male adults) in Latin America(all income levels) in 1977 to that in 1978?
Your answer should be very brief. 1.02. What is the ratio of the Mortality Rate(per 1000 female or male adults) of High income: OECD in 1977 to that in 1979?
Make the answer very short. 1.04. What is the ratio of the Mortality Rate(per 1000 female or male adults) of Latin America(all income levels) in 1977 to that in 1979?
Give a very brief answer. 1.04. What is the ratio of the Mortality Rate(per 1000 female or male adults) in Bangladesh in 1977 to that in 1979?
Ensure brevity in your answer.  1.02. What is the ratio of the Mortality Rate(per 1000 female or male adults) in High income: OECD in 1978 to that in 1979?
Provide a short and direct response. 1.02. What is the ratio of the Mortality Rate(per 1000 female or male adults) of Latin America(all income levels) in 1978 to that in 1979?
Give a very brief answer. 1.02. What is the ratio of the Mortality Rate(per 1000 female or male adults) in Bangladesh in 1978 to that in 1979?
Your answer should be very brief. 1.01. What is the difference between the highest and the second highest Mortality Rate(per 1000 female or male adults) in High income: OECD?
Your response must be concise. 1.68. What is the difference between the highest and the second highest Mortality Rate(per 1000 female or male adults) of Latin America(all income levels)?
Offer a terse response. 3.09. What is the difference between the highest and the second highest Mortality Rate(per 1000 female or male adults) in Bangladesh?
Offer a terse response. 5.61. What is the difference between the highest and the lowest Mortality Rate(per 1000 female or male adults) of High income: OECD?
Your response must be concise. 16.35. What is the difference between the highest and the lowest Mortality Rate(per 1000 female or male adults) in Latin America(all income levels)?
Offer a terse response. 22.19. What is the difference between the highest and the lowest Mortality Rate(per 1000 female or male adults) in Bangladesh?
Your answer should be compact. 33.41. 